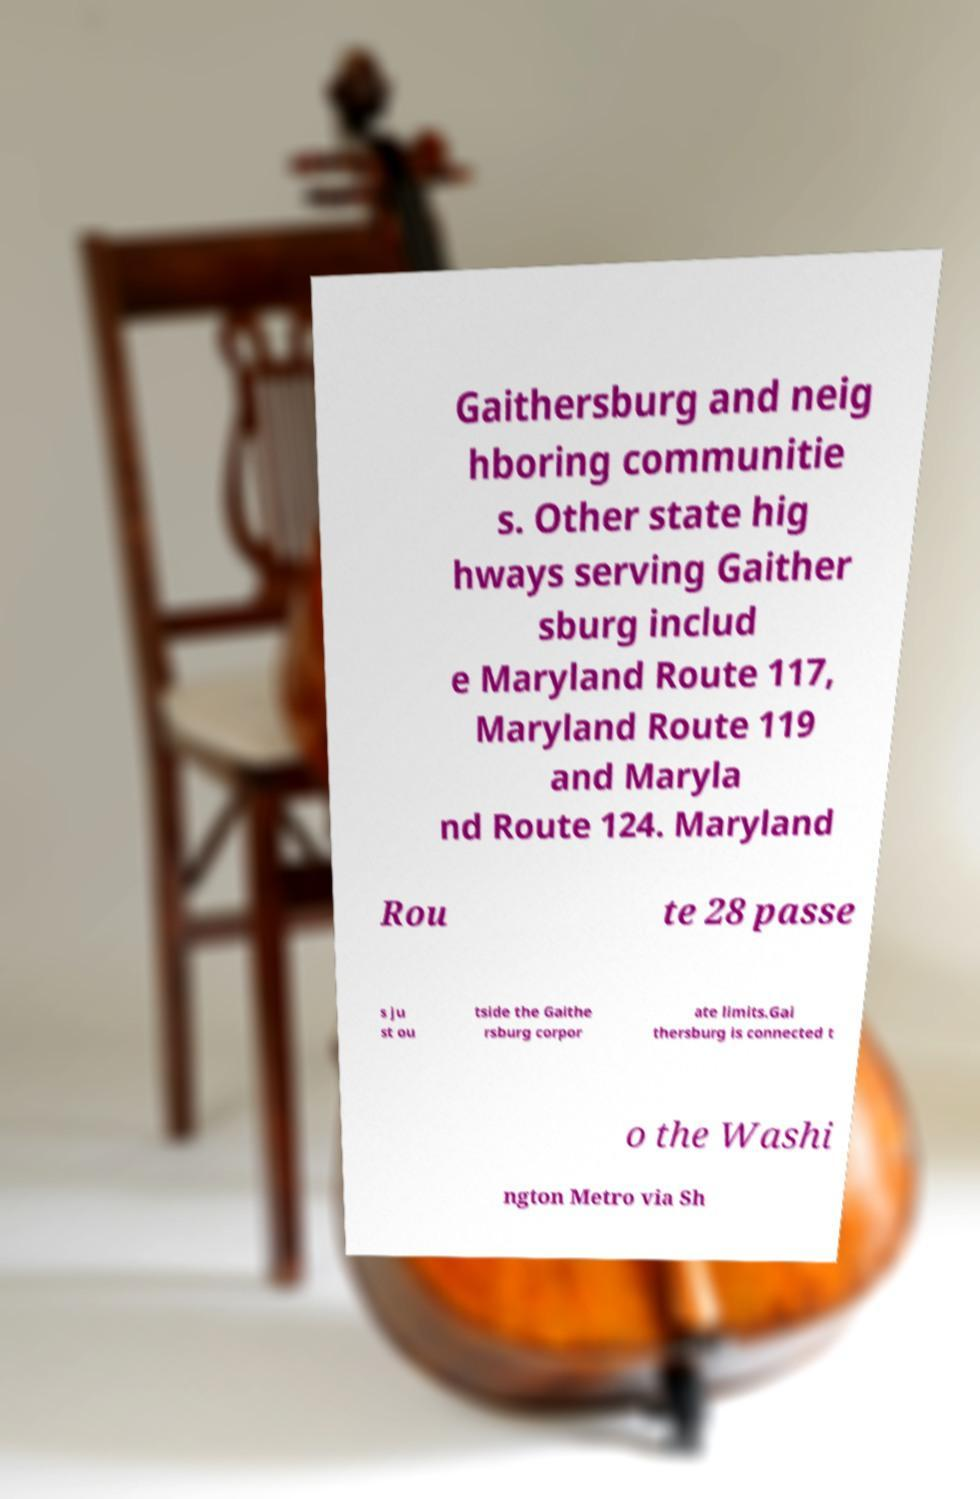Could you assist in decoding the text presented in this image and type it out clearly? Gaithersburg and neig hboring communitie s. Other state hig hways serving Gaither sburg includ e Maryland Route 117, Maryland Route 119 and Maryla nd Route 124. Maryland Rou te 28 passe s ju st ou tside the Gaithe rsburg corpor ate limits.Gai thersburg is connected t o the Washi ngton Metro via Sh 